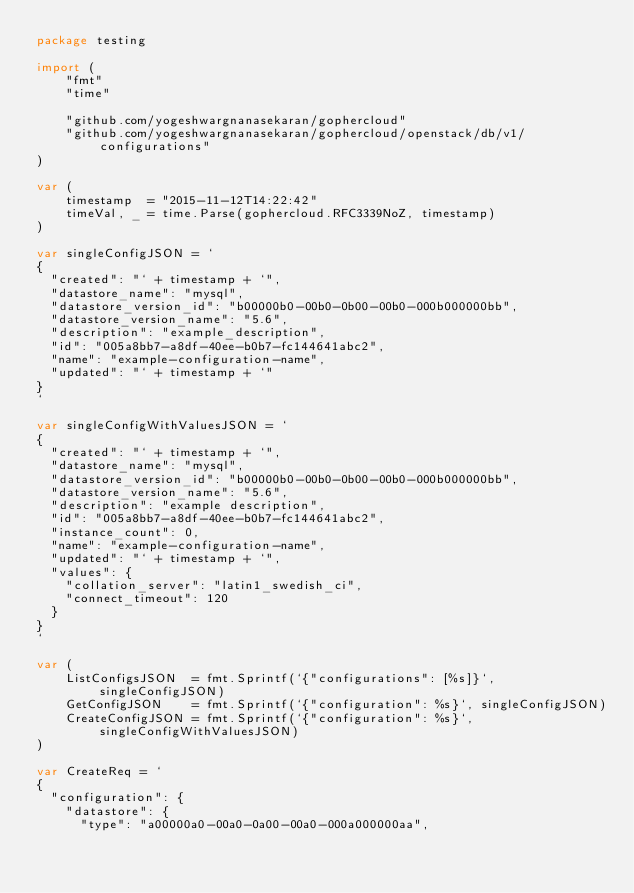Convert code to text. <code><loc_0><loc_0><loc_500><loc_500><_Go_>package testing

import (
	"fmt"
	"time"

	"github.com/yogeshwargnanasekaran/gophercloud"
	"github.com/yogeshwargnanasekaran/gophercloud/openstack/db/v1/configurations"
)

var (
	timestamp  = "2015-11-12T14:22:42"
	timeVal, _ = time.Parse(gophercloud.RFC3339NoZ, timestamp)
)

var singleConfigJSON = `
{
  "created": "` + timestamp + `",
  "datastore_name": "mysql",
  "datastore_version_id": "b00000b0-00b0-0b00-00b0-000b000000bb",
  "datastore_version_name": "5.6",
  "description": "example_description",
  "id": "005a8bb7-a8df-40ee-b0b7-fc144641abc2",
  "name": "example-configuration-name",
  "updated": "` + timestamp + `"
}
`

var singleConfigWithValuesJSON = `
{
  "created": "` + timestamp + `",
  "datastore_name": "mysql",
  "datastore_version_id": "b00000b0-00b0-0b00-00b0-000b000000bb",
  "datastore_version_name": "5.6",
  "description": "example description",
  "id": "005a8bb7-a8df-40ee-b0b7-fc144641abc2",
  "instance_count": 0,
  "name": "example-configuration-name",
  "updated": "` + timestamp + `",
  "values": {
    "collation_server": "latin1_swedish_ci",
    "connect_timeout": 120
  }
}
`

var (
	ListConfigsJSON  = fmt.Sprintf(`{"configurations": [%s]}`, singleConfigJSON)
	GetConfigJSON    = fmt.Sprintf(`{"configuration": %s}`, singleConfigJSON)
	CreateConfigJSON = fmt.Sprintf(`{"configuration": %s}`, singleConfigWithValuesJSON)
)

var CreateReq = `
{
  "configuration": {
    "datastore": {
      "type": "a00000a0-00a0-0a00-00a0-000a000000aa",</code> 